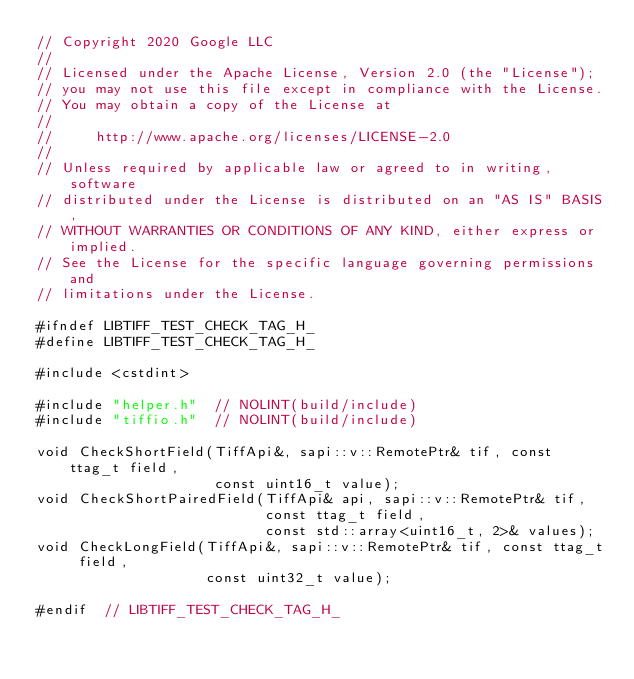<code> <loc_0><loc_0><loc_500><loc_500><_C_>// Copyright 2020 Google LLC
//
// Licensed under the Apache License, Version 2.0 (the "License");
// you may not use this file except in compliance with the License.
// You may obtain a copy of the License at
//
//     http://www.apache.org/licenses/LICENSE-2.0
//
// Unless required by applicable law or agreed to in writing, software
// distributed under the License is distributed on an "AS IS" BASIS,
// WITHOUT WARRANTIES OR CONDITIONS OF ANY KIND, either express or implied.
// See the License for the specific language governing permissions and
// limitations under the License.

#ifndef LIBTIFF_TEST_CHECK_TAG_H_
#define LIBTIFF_TEST_CHECK_TAG_H_

#include <cstdint>

#include "helper.h"  // NOLINT(build/include)
#include "tiffio.h"  // NOLINT(build/include)

void CheckShortField(TiffApi&, sapi::v::RemotePtr& tif, const ttag_t field,
                     const uint16_t value);
void CheckShortPairedField(TiffApi& api, sapi::v::RemotePtr& tif,
                           const ttag_t field,
                           const std::array<uint16_t, 2>& values);
void CheckLongField(TiffApi&, sapi::v::RemotePtr& tif, const ttag_t field,
                    const uint32_t value);

#endif  // LIBTIFF_TEST_CHECK_TAG_H_
</code> 